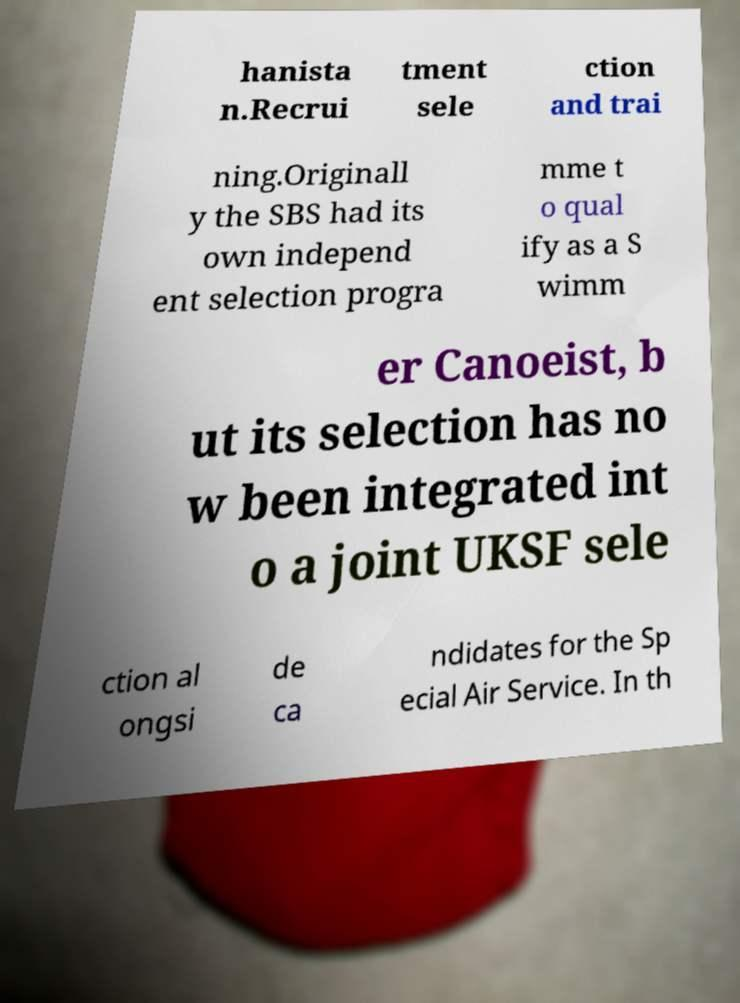Can you accurately transcribe the text from the provided image for me? hanista n.Recrui tment sele ction and trai ning.Originall y the SBS had its own independ ent selection progra mme t o qual ify as a S wimm er Canoeist, b ut its selection has no w been integrated int o a joint UKSF sele ction al ongsi de ca ndidates for the Sp ecial Air Service. In th 